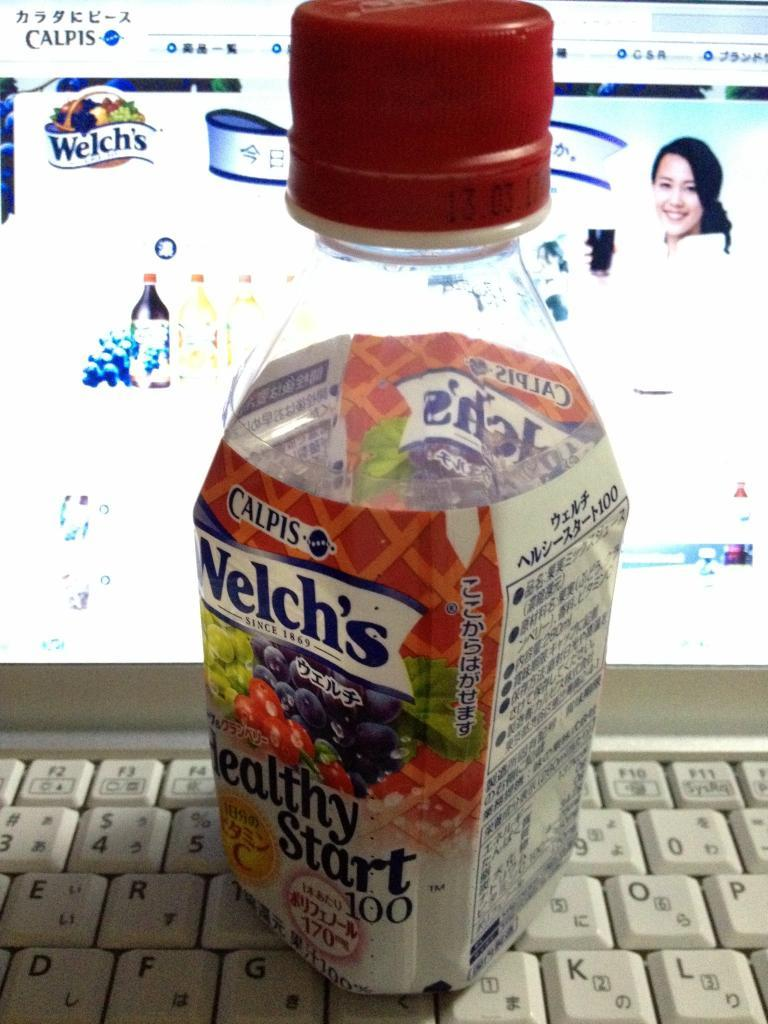<image>
Summarize the visual content of the image. A Welch's fruit beverage sitting on top of a laptop. 